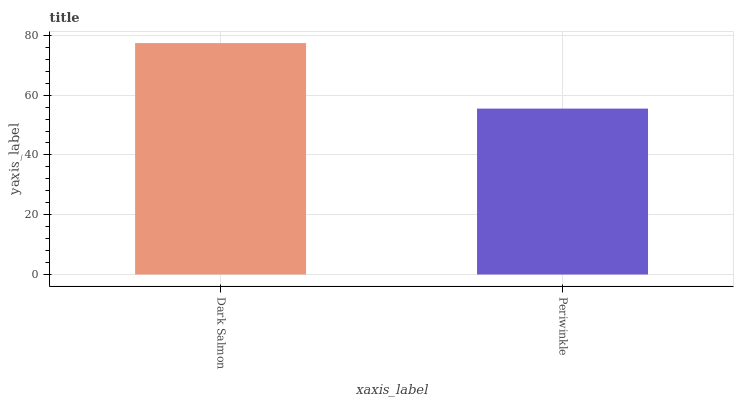Is Periwinkle the maximum?
Answer yes or no. No. Is Dark Salmon greater than Periwinkle?
Answer yes or no. Yes. Is Periwinkle less than Dark Salmon?
Answer yes or no. Yes. Is Periwinkle greater than Dark Salmon?
Answer yes or no. No. Is Dark Salmon less than Periwinkle?
Answer yes or no. No. Is Dark Salmon the high median?
Answer yes or no. Yes. Is Periwinkle the low median?
Answer yes or no. Yes. Is Periwinkle the high median?
Answer yes or no. No. Is Dark Salmon the low median?
Answer yes or no. No. 